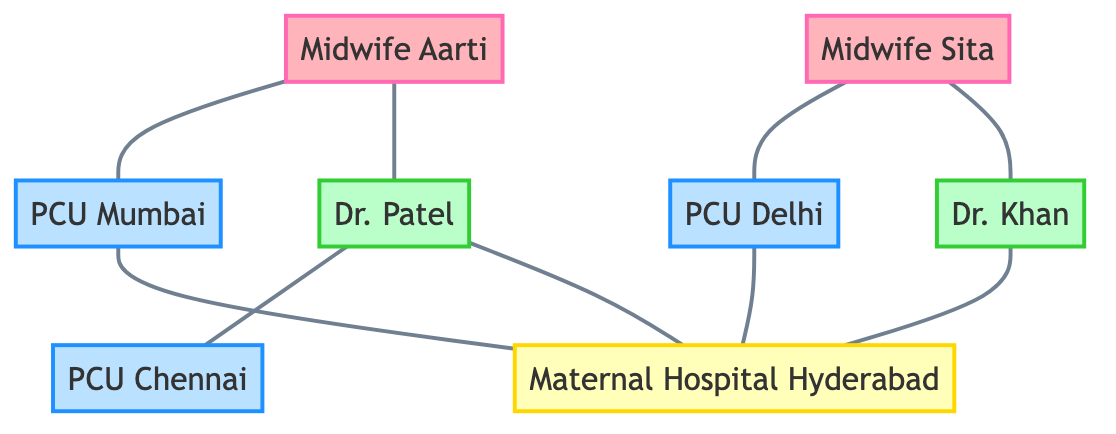What is the total number of nodes in the diagram? The diagram contains eight nodes representing different maternal health service providers and their locations: Midwife Aarti, Midwife Sita, Dr. Patel, Dr. Khan, Primary Care Unit Mumbai, Primary Care Unit Delhi, Primary Care Unit Chennai, and Maternal Hospital Hyderabad. Counting these gives a total of eight nodes.
Answer: 8 How many Primary Care Units are depicted in the diagram? The diagram shows three Primary Care Units: Primary Care Unit Mumbai, Primary Care Unit Delhi, and Primary Care Unit Chennai. Therefore, there are three Primary Care Units in total.
Answer: 3 Which midwife is connected to Dr. Patel? Referring to the edges in the diagram, Midwife Aarti is connected to Dr. Patel, indicating a direct link between them.
Answer: Midwife Aarti How many edges connect to Maternal Hospital Hyderabad? The diagram indicates that there are five edges leading to Maternal Hospital Hyderabad, connecting it with Dr. Patel, Dr. Khan, Primary Care Unit Mumbai, and Primary Care Unit Delhi. Counting these gives a total of five connections.
Answer: 5 Which Primary Care Unit is connected to Midwife Sita? From the diagram, it can be seen that Midwife Sita is connected to Primary Care Unit Delhi, indicating a direct association between them.
Answer: Primary Care Unit Delhi Is there a connection between Midwife Aarti and Maternal Hospital Hyderabad? Yes, there is an edge between Midwife Aarti and Maternal Hospital Hyderabad, demonstrating that Aarti has a direct connection to this hospital.
Answer: Yes How many obstetricians are connected to Maternal Hospital Hyderabad? The diagram reveals that two obstetricians, Dr. Patel and Dr. Khan, are connected to Maternal Hospital Hyderabad. Thus, the count of obstetricians connected is two.
Answer: 2 Are there any connections between the Primary Care Units and each other? The diagram shows no edges between the Primary Care Units themselves; they are only connected to midwives and the Maternal Hospital. Therefore, there are no connections between the Primary Care Units.
Answer: No What role does Midwife Aarti play in the network? Midwife Aarti is identified in the diagram as a Midwife, which indicates her professional role in the maternal health service provider network.
Answer: Midwife 